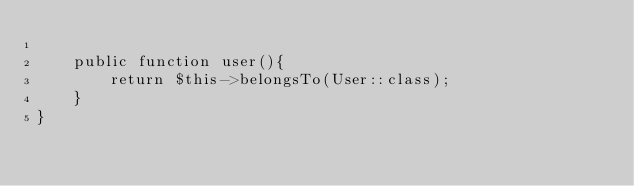Convert code to text. <code><loc_0><loc_0><loc_500><loc_500><_PHP_>
    public function user(){
        return $this->belongsTo(User::class);
    }
}
</code> 